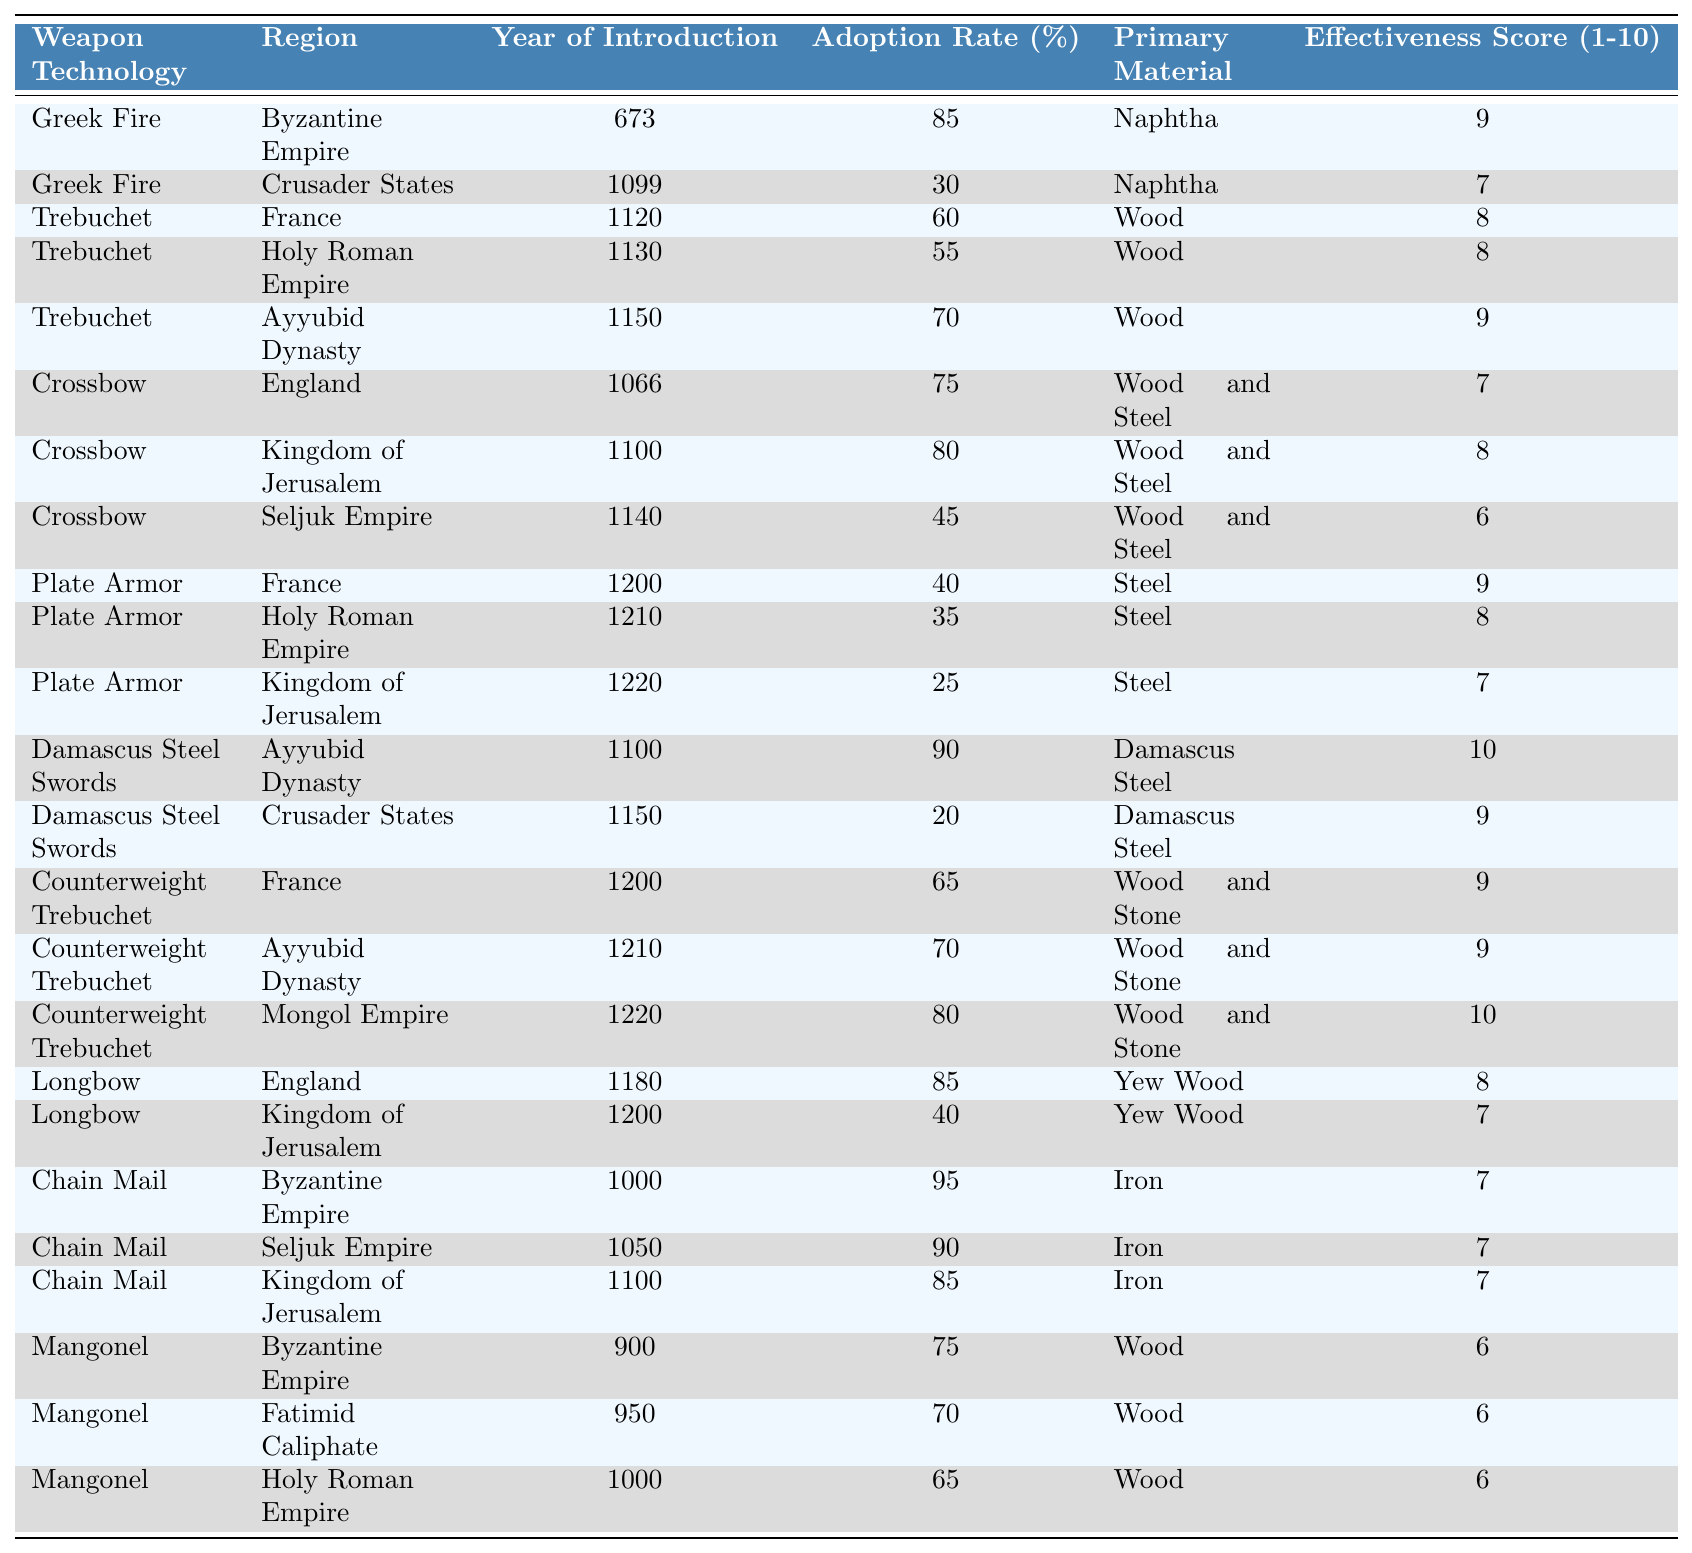What was the adoption rate of Greek Fire in the Crusader States? The table shows that Greek Fire had an adoption rate of 30% in the Crusader States.
Answer: 30% Which weapon introduced the earliest according to the table? Greek Fire, introduced in the year 673, is the earliest weapon noted in the table.
Answer: Greek Fire What is the average effectiveness score of the weapons used by the Ayyubid Dynasty? The effectiveness scores for the Ayyubid Dynasty's weapons are 9 (Trebuchet), 10 (Damascus Steel Swords), 9 (Counterweight Trebuchet). The average is (9 + 10 + 9) / 3 = 9.
Answer: 9 Did the Kingdom of Jerusalem adopt Plate Armor before or after the introduction of Longbow? Plate Armor was introduced in 1220 while Longbow was introduced in 1200, so Plate Armor was adopted after Longbow.
Answer: After Which region had the highest adoption rate for Chain Mail? The Byzantine Empire had the highest adoption rate for Chain Mail at 95%.
Answer: Byzantine Empire How many distinct weapon technologies had an adoption rate of 60% or higher? The weapon technologies with an adoption rate of 60% or higher are Greek Fire (85% in Byzantine Empire), Trebuchet (60% in France), Ayyubid Dynasty (70% in Trebuchet), Crossbow (80% in Kingdom of Jerusalem), Damascus Steel Swords (90% in Ayyubid Dynasty), Counterweight Trebuchet (65% in France), and Counterweight Trebuchet (80% in Mongol Empire). This counts to a total of 7 distinct technologies.
Answer: 7 What is the primary material used for the majority of the weapons listed in the table? Most of the weapons use wood or combinations with metal, such as wood and steel. Specifically, wood is used for Mangonel, Trebuchet, and others like Crossbow.
Answer: Wood Which weapon technology introduced in the Holy Roman Empire has the lowest adoption rate? The Plate Armor introduced in the Holy Roman Empire in 1210 has the lowest adoption rate at 35%.
Answer: 35% Was there a weapon technology that scored a perfect effectiveness score of 10? Yes, Damascus Steel Swords had a perfect effectiveness score of 10 in the Ayyubid Dynasty.
Answer: Yes What regions adopted Greek Fire and what was its effectiveness score in those regions? Greek Fire was adopted in the Byzantine Empire (score 9) and the Crusader States (score 7).
Answer: Byzantine Empire (9), Crusader States (7) 